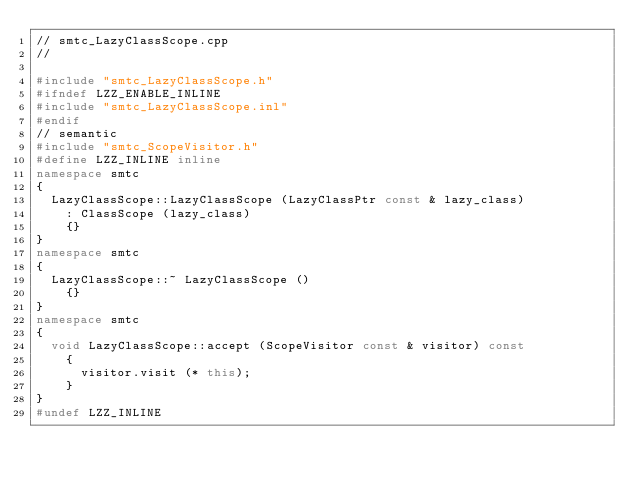<code> <loc_0><loc_0><loc_500><loc_500><_C++_>// smtc_LazyClassScope.cpp
//

#include "smtc_LazyClassScope.h"
#ifndef LZZ_ENABLE_INLINE
#include "smtc_LazyClassScope.inl"
#endif
// semantic
#include "smtc_ScopeVisitor.h"
#define LZZ_INLINE inline
namespace smtc
{
  LazyClassScope::LazyClassScope (LazyClassPtr const & lazy_class)
    : ClassScope (lazy_class)
    {}
}
namespace smtc
{
  LazyClassScope::~ LazyClassScope ()
    {}
}
namespace smtc
{
  void LazyClassScope::accept (ScopeVisitor const & visitor) const
    {
      visitor.visit (* this);
    }
}
#undef LZZ_INLINE
</code> 